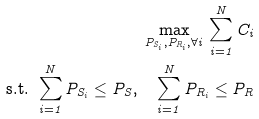<formula> <loc_0><loc_0><loc_500><loc_500>\max _ { P _ { S _ { i } } , P _ { R _ { i } } , \forall i } \, \sum _ { i = 1 } ^ { N } C _ { i } \\ \text { s.t. } \sum _ { i = 1 } ^ { N } P _ { S _ { i } } \leq P _ { S } , \quad \sum _ { i = 1 } ^ { N } P _ { R _ { i } } \leq P _ { R }</formula> 